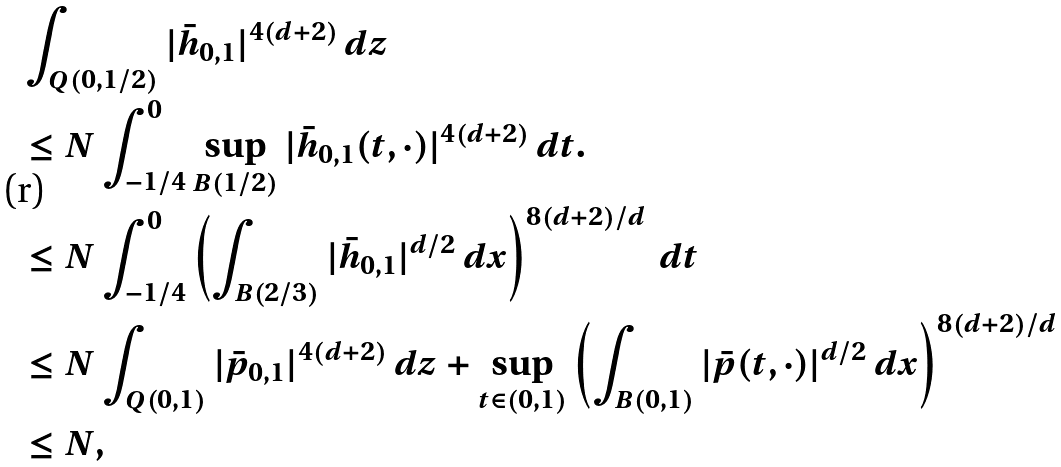Convert formula to latex. <formula><loc_0><loc_0><loc_500><loc_500>& \int _ { Q ( 0 , 1 / 2 ) } | \bar { h } _ { 0 , 1 } | ^ { 4 ( d + 2 ) } \, d z \\ & \leq N \int _ { - 1 / 4 } ^ { 0 } \sup _ { B ( 1 / 2 ) } | \bar { h } _ { 0 , 1 } ( t , \cdot ) | ^ { 4 ( d + 2 ) } \, d t . \\ & \leq N \int _ { - 1 / 4 } ^ { 0 } \left ( \int _ { B ( 2 / 3 ) } | \bar { h } _ { 0 , 1 } | ^ { d / 2 } \, d x \right ) ^ { 8 ( d + 2 ) / d } \, d t \\ & \leq N \int _ { Q ( 0 , 1 ) } | { \bar { p } } _ { 0 , 1 } | ^ { 4 ( d + 2 ) } \, d z + \sup _ { t \in ( 0 , 1 ) } \left ( \int _ { B ( 0 , 1 ) } | \bar { p } ( t , \cdot ) | ^ { d / 2 } \, d x \right ) ^ { 8 ( d + 2 ) / d } \\ & \leq N ,</formula> 